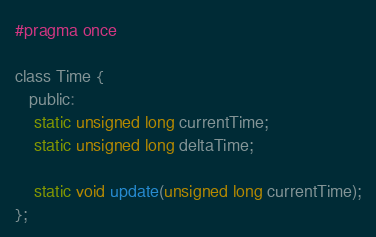<code> <loc_0><loc_0><loc_500><loc_500><_C_>#pragma once

class Time {
   public:
    static unsigned long currentTime;
    static unsigned long deltaTime;

    static void update(unsigned long currentTime);
};</code> 